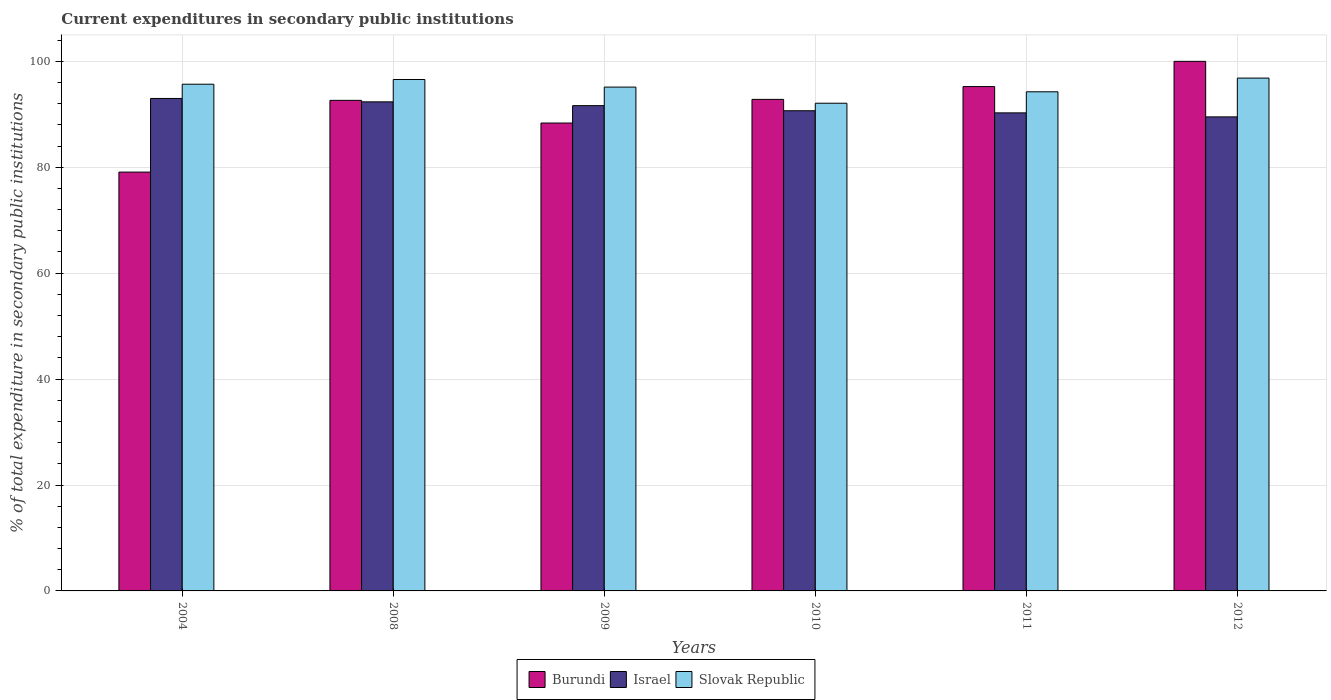How many different coloured bars are there?
Make the answer very short. 3. How many bars are there on the 1st tick from the right?
Offer a very short reply. 3. What is the current expenditures in secondary public institutions in Israel in 2012?
Your answer should be very brief. 89.51. Across all years, what is the maximum current expenditures in secondary public institutions in Slovak Republic?
Your response must be concise. 96.84. Across all years, what is the minimum current expenditures in secondary public institutions in Slovak Republic?
Keep it short and to the point. 92.09. In which year was the current expenditures in secondary public institutions in Slovak Republic maximum?
Ensure brevity in your answer.  2012. In which year was the current expenditures in secondary public institutions in Slovak Republic minimum?
Provide a short and direct response. 2010. What is the total current expenditures in secondary public institutions in Israel in the graph?
Keep it short and to the point. 547.41. What is the difference between the current expenditures in secondary public institutions in Israel in 2009 and that in 2012?
Offer a very short reply. 2.12. What is the difference between the current expenditures in secondary public institutions in Slovak Republic in 2008 and the current expenditures in secondary public institutions in Burundi in 2004?
Your response must be concise. 17.48. What is the average current expenditures in secondary public institutions in Israel per year?
Provide a succinct answer. 91.24. In the year 2008, what is the difference between the current expenditures in secondary public institutions in Slovak Republic and current expenditures in secondary public institutions in Israel?
Make the answer very short. 4.22. What is the ratio of the current expenditures in secondary public institutions in Burundi in 2009 to that in 2011?
Keep it short and to the point. 0.93. Is the difference between the current expenditures in secondary public institutions in Slovak Republic in 2008 and 2009 greater than the difference between the current expenditures in secondary public institutions in Israel in 2008 and 2009?
Keep it short and to the point. Yes. What is the difference between the highest and the second highest current expenditures in secondary public institutions in Israel?
Provide a succinct answer. 0.64. What is the difference between the highest and the lowest current expenditures in secondary public institutions in Israel?
Offer a terse response. 3.48. In how many years, is the current expenditures in secondary public institutions in Burundi greater than the average current expenditures in secondary public institutions in Burundi taken over all years?
Make the answer very short. 4. Is the sum of the current expenditures in secondary public institutions in Slovak Republic in 2011 and 2012 greater than the maximum current expenditures in secondary public institutions in Israel across all years?
Offer a terse response. Yes. What does the 2nd bar from the left in 2010 represents?
Make the answer very short. Israel. What does the 3rd bar from the right in 2009 represents?
Give a very brief answer. Burundi. Is it the case that in every year, the sum of the current expenditures in secondary public institutions in Burundi and current expenditures in secondary public institutions in Israel is greater than the current expenditures in secondary public institutions in Slovak Republic?
Your answer should be compact. Yes. Are all the bars in the graph horizontal?
Offer a terse response. No. How many years are there in the graph?
Your response must be concise. 6. What is the difference between two consecutive major ticks on the Y-axis?
Give a very brief answer. 20. Are the values on the major ticks of Y-axis written in scientific E-notation?
Make the answer very short. No. Where does the legend appear in the graph?
Provide a short and direct response. Bottom center. How are the legend labels stacked?
Your response must be concise. Horizontal. What is the title of the graph?
Your answer should be compact. Current expenditures in secondary public institutions. Does "Netherlands" appear as one of the legend labels in the graph?
Make the answer very short. No. What is the label or title of the Y-axis?
Your response must be concise. % of total expenditure in secondary public institutions. What is the % of total expenditure in secondary public institutions in Burundi in 2004?
Give a very brief answer. 79.09. What is the % of total expenditure in secondary public institutions in Israel in 2004?
Provide a succinct answer. 92.99. What is the % of total expenditure in secondary public institutions of Slovak Republic in 2004?
Your response must be concise. 95.68. What is the % of total expenditure in secondary public institutions in Burundi in 2008?
Ensure brevity in your answer.  92.63. What is the % of total expenditure in secondary public institutions in Israel in 2008?
Give a very brief answer. 92.35. What is the % of total expenditure in secondary public institutions of Slovak Republic in 2008?
Offer a very short reply. 96.57. What is the % of total expenditure in secondary public institutions of Burundi in 2009?
Provide a succinct answer. 88.35. What is the % of total expenditure in secondary public institutions in Israel in 2009?
Your answer should be compact. 91.63. What is the % of total expenditure in secondary public institutions in Slovak Republic in 2009?
Provide a short and direct response. 95.13. What is the % of total expenditure in secondary public institutions of Burundi in 2010?
Provide a succinct answer. 92.81. What is the % of total expenditure in secondary public institutions in Israel in 2010?
Make the answer very short. 90.67. What is the % of total expenditure in secondary public institutions of Slovak Republic in 2010?
Provide a short and direct response. 92.09. What is the % of total expenditure in secondary public institutions of Burundi in 2011?
Your answer should be compact. 95.23. What is the % of total expenditure in secondary public institutions of Israel in 2011?
Your answer should be compact. 90.27. What is the % of total expenditure in secondary public institutions of Slovak Republic in 2011?
Your answer should be compact. 94.25. What is the % of total expenditure in secondary public institutions in Burundi in 2012?
Ensure brevity in your answer.  100. What is the % of total expenditure in secondary public institutions in Israel in 2012?
Ensure brevity in your answer.  89.51. What is the % of total expenditure in secondary public institutions in Slovak Republic in 2012?
Offer a terse response. 96.84. Across all years, what is the maximum % of total expenditure in secondary public institutions in Burundi?
Provide a succinct answer. 100. Across all years, what is the maximum % of total expenditure in secondary public institutions in Israel?
Provide a succinct answer. 92.99. Across all years, what is the maximum % of total expenditure in secondary public institutions of Slovak Republic?
Provide a succinct answer. 96.84. Across all years, what is the minimum % of total expenditure in secondary public institutions of Burundi?
Keep it short and to the point. 79.09. Across all years, what is the minimum % of total expenditure in secondary public institutions of Israel?
Make the answer very short. 89.51. Across all years, what is the minimum % of total expenditure in secondary public institutions in Slovak Republic?
Provide a succinct answer. 92.09. What is the total % of total expenditure in secondary public institutions of Burundi in the graph?
Your answer should be compact. 548.11. What is the total % of total expenditure in secondary public institutions in Israel in the graph?
Keep it short and to the point. 547.41. What is the total % of total expenditure in secondary public institutions of Slovak Republic in the graph?
Offer a terse response. 570.56. What is the difference between the % of total expenditure in secondary public institutions of Burundi in 2004 and that in 2008?
Keep it short and to the point. -13.54. What is the difference between the % of total expenditure in secondary public institutions in Israel in 2004 and that in 2008?
Your answer should be very brief. 0.64. What is the difference between the % of total expenditure in secondary public institutions of Slovak Republic in 2004 and that in 2008?
Give a very brief answer. -0.89. What is the difference between the % of total expenditure in secondary public institutions of Burundi in 2004 and that in 2009?
Make the answer very short. -9.26. What is the difference between the % of total expenditure in secondary public institutions of Israel in 2004 and that in 2009?
Provide a succinct answer. 1.36. What is the difference between the % of total expenditure in secondary public institutions of Slovak Republic in 2004 and that in 2009?
Keep it short and to the point. 0.54. What is the difference between the % of total expenditure in secondary public institutions in Burundi in 2004 and that in 2010?
Your answer should be compact. -13.73. What is the difference between the % of total expenditure in secondary public institutions in Israel in 2004 and that in 2010?
Provide a succinct answer. 2.32. What is the difference between the % of total expenditure in secondary public institutions of Slovak Republic in 2004 and that in 2010?
Your response must be concise. 3.59. What is the difference between the % of total expenditure in secondary public institutions of Burundi in 2004 and that in 2011?
Offer a very short reply. -16.15. What is the difference between the % of total expenditure in secondary public institutions of Israel in 2004 and that in 2011?
Give a very brief answer. 2.72. What is the difference between the % of total expenditure in secondary public institutions of Slovak Republic in 2004 and that in 2011?
Keep it short and to the point. 1.43. What is the difference between the % of total expenditure in secondary public institutions of Burundi in 2004 and that in 2012?
Your answer should be compact. -20.91. What is the difference between the % of total expenditure in secondary public institutions in Israel in 2004 and that in 2012?
Keep it short and to the point. 3.48. What is the difference between the % of total expenditure in secondary public institutions of Slovak Republic in 2004 and that in 2012?
Your answer should be compact. -1.16. What is the difference between the % of total expenditure in secondary public institutions in Burundi in 2008 and that in 2009?
Offer a very short reply. 4.28. What is the difference between the % of total expenditure in secondary public institutions in Israel in 2008 and that in 2009?
Offer a terse response. 0.72. What is the difference between the % of total expenditure in secondary public institutions of Slovak Republic in 2008 and that in 2009?
Offer a very short reply. 1.43. What is the difference between the % of total expenditure in secondary public institutions in Burundi in 2008 and that in 2010?
Offer a very short reply. -0.18. What is the difference between the % of total expenditure in secondary public institutions in Israel in 2008 and that in 2010?
Your answer should be compact. 1.68. What is the difference between the % of total expenditure in secondary public institutions of Slovak Republic in 2008 and that in 2010?
Your response must be concise. 4.48. What is the difference between the % of total expenditure in secondary public institutions in Burundi in 2008 and that in 2011?
Your answer should be very brief. -2.6. What is the difference between the % of total expenditure in secondary public institutions of Israel in 2008 and that in 2011?
Offer a terse response. 2.08. What is the difference between the % of total expenditure in secondary public institutions in Slovak Republic in 2008 and that in 2011?
Your response must be concise. 2.32. What is the difference between the % of total expenditure in secondary public institutions in Burundi in 2008 and that in 2012?
Provide a short and direct response. -7.37. What is the difference between the % of total expenditure in secondary public institutions of Israel in 2008 and that in 2012?
Provide a succinct answer. 2.84. What is the difference between the % of total expenditure in secondary public institutions of Slovak Republic in 2008 and that in 2012?
Your answer should be very brief. -0.27. What is the difference between the % of total expenditure in secondary public institutions in Burundi in 2009 and that in 2010?
Give a very brief answer. -4.46. What is the difference between the % of total expenditure in secondary public institutions of Israel in 2009 and that in 2010?
Your answer should be compact. 0.96. What is the difference between the % of total expenditure in secondary public institutions in Slovak Republic in 2009 and that in 2010?
Provide a succinct answer. 3.05. What is the difference between the % of total expenditure in secondary public institutions of Burundi in 2009 and that in 2011?
Your response must be concise. -6.88. What is the difference between the % of total expenditure in secondary public institutions in Israel in 2009 and that in 2011?
Provide a short and direct response. 1.36. What is the difference between the % of total expenditure in secondary public institutions of Slovak Republic in 2009 and that in 2011?
Keep it short and to the point. 0.89. What is the difference between the % of total expenditure in secondary public institutions of Burundi in 2009 and that in 2012?
Provide a short and direct response. -11.64. What is the difference between the % of total expenditure in secondary public institutions of Israel in 2009 and that in 2012?
Make the answer very short. 2.12. What is the difference between the % of total expenditure in secondary public institutions in Slovak Republic in 2009 and that in 2012?
Offer a very short reply. -1.7. What is the difference between the % of total expenditure in secondary public institutions in Burundi in 2010 and that in 2011?
Make the answer very short. -2.42. What is the difference between the % of total expenditure in secondary public institutions in Israel in 2010 and that in 2011?
Make the answer very short. 0.4. What is the difference between the % of total expenditure in secondary public institutions in Slovak Republic in 2010 and that in 2011?
Give a very brief answer. -2.16. What is the difference between the % of total expenditure in secondary public institutions of Burundi in 2010 and that in 2012?
Give a very brief answer. -7.18. What is the difference between the % of total expenditure in secondary public institutions in Israel in 2010 and that in 2012?
Offer a terse response. 1.16. What is the difference between the % of total expenditure in secondary public institutions in Slovak Republic in 2010 and that in 2012?
Your answer should be very brief. -4.75. What is the difference between the % of total expenditure in secondary public institutions of Burundi in 2011 and that in 2012?
Your answer should be very brief. -4.76. What is the difference between the % of total expenditure in secondary public institutions in Israel in 2011 and that in 2012?
Your response must be concise. 0.76. What is the difference between the % of total expenditure in secondary public institutions in Slovak Republic in 2011 and that in 2012?
Your answer should be compact. -2.59. What is the difference between the % of total expenditure in secondary public institutions of Burundi in 2004 and the % of total expenditure in secondary public institutions of Israel in 2008?
Provide a succinct answer. -13.26. What is the difference between the % of total expenditure in secondary public institutions in Burundi in 2004 and the % of total expenditure in secondary public institutions in Slovak Republic in 2008?
Make the answer very short. -17.48. What is the difference between the % of total expenditure in secondary public institutions of Israel in 2004 and the % of total expenditure in secondary public institutions of Slovak Republic in 2008?
Make the answer very short. -3.58. What is the difference between the % of total expenditure in secondary public institutions of Burundi in 2004 and the % of total expenditure in secondary public institutions of Israel in 2009?
Give a very brief answer. -12.54. What is the difference between the % of total expenditure in secondary public institutions in Burundi in 2004 and the % of total expenditure in secondary public institutions in Slovak Republic in 2009?
Make the answer very short. -16.05. What is the difference between the % of total expenditure in secondary public institutions of Israel in 2004 and the % of total expenditure in secondary public institutions of Slovak Republic in 2009?
Ensure brevity in your answer.  -2.15. What is the difference between the % of total expenditure in secondary public institutions of Burundi in 2004 and the % of total expenditure in secondary public institutions of Israel in 2010?
Offer a terse response. -11.58. What is the difference between the % of total expenditure in secondary public institutions in Burundi in 2004 and the % of total expenditure in secondary public institutions in Slovak Republic in 2010?
Keep it short and to the point. -13. What is the difference between the % of total expenditure in secondary public institutions in Israel in 2004 and the % of total expenditure in secondary public institutions in Slovak Republic in 2010?
Ensure brevity in your answer.  0.9. What is the difference between the % of total expenditure in secondary public institutions in Burundi in 2004 and the % of total expenditure in secondary public institutions in Israel in 2011?
Your response must be concise. -11.18. What is the difference between the % of total expenditure in secondary public institutions of Burundi in 2004 and the % of total expenditure in secondary public institutions of Slovak Republic in 2011?
Make the answer very short. -15.16. What is the difference between the % of total expenditure in secondary public institutions in Israel in 2004 and the % of total expenditure in secondary public institutions in Slovak Republic in 2011?
Offer a terse response. -1.26. What is the difference between the % of total expenditure in secondary public institutions of Burundi in 2004 and the % of total expenditure in secondary public institutions of Israel in 2012?
Your answer should be very brief. -10.42. What is the difference between the % of total expenditure in secondary public institutions in Burundi in 2004 and the % of total expenditure in secondary public institutions in Slovak Republic in 2012?
Your answer should be very brief. -17.75. What is the difference between the % of total expenditure in secondary public institutions in Israel in 2004 and the % of total expenditure in secondary public institutions in Slovak Republic in 2012?
Give a very brief answer. -3.85. What is the difference between the % of total expenditure in secondary public institutions of Burundi in 2008 and the % of total expenditure in secondary public institutions of Israel in 2009?
Offer a very short reply. 1. What is the difference between the % of total expenditure in secondary public institutions in Burundi in 2008 and the % of total expenditure in secondary public institutions in Slovak Republic in 2009?
Offer a terse response. -2.5. What is the difference between the % of total expenditure in secondary public institutions in Israel in 2008 and the % of total expenditure in secondary public institutions in Slovak Republic in 2009?
Your answer should be compact. -2.79. What is the difference between the % of total expenditure in secondary public institutions of Burundi in 2008 and the % of total expenditure in secondary public institutions of Israel in 2010?
Provide a succinct answer. 1.96. What is the difference between the % of total expenditure in secondary public institutions of Burundi in 2008 and the % of total expenditure in secondary public institutions of Slovak Republic in 2010?
Keep it short and to the point. 0.54. What is the difference between the % of total expenditure in secondary public institutions in Israel in 2008 and the % of total expenditure in secondary public institutions in Slovak Republic in 2010?
Offer a very short reply. 0.26. What is the difference between the % of total expenditure in secondary public institutions of Burundi in 2008 and the % of total expenditure in secondary public institutions of Israel in 2011?
Provide a short and direct response. 2.36. What is the difference between the % of total expenditure in secondary public institutions in Burundi in 2008 and the % of total expenditure in secondary public institutions in Slovak Republic in 2011?
Your answer should be very brief. -1.62. What is the difference between the % of total expenditure in secondary public institutions of Israel in 2008 and the % of total expenditure in secondary public institutions of Slovak Republic in 2011?
Offer a terse response. -1.9. What is the difference between the % of total expenditure in secondary public institutions of Burundi in 2008 and the % of total expenditure in secondary public institutions of Israel in 2012?
Give a very brief answer. 3.12. What is the difference between the % of total expenditure in secondary public institutions of Burundi in 2008 and the % of total expenditure in secondary public institutions of Slovak Republic in 2012?
Make the answer very short. -4.21. What is the difference between the % of total expenditure in secondary public institutions in Israel in 2008 and the % of total expenditure in secondary public institutions in Slovak Republic in 2012?
Make the answer very short. -4.49. What is the difference between the % of total expenditure in secondary public institutions in Burundi in 2009 and the % of total expenditure in secondary public institutions in Israel in 2010?
Provide a succinct answer. -2.32. What is the difference between the % of total expenditure in secondary public institutions of Burundi in 2009 and the % of total expenditure in secondary public institutions of Slovak Republic in 2010?
Make the answer very short. -3.74. What is the difference between the % of total expenditure in secondary public institutions in Israel in 2009 and the % of total expenditure in secondary public institutions in Slovak Republic in 2010?
Your answer should be compact. -0.46. What is the difference between the % of total expenditure in secondary public institutions in Burundi in 2009 and the % of total expenditure in secondary public institutions in Israel in 2011?
Make the answer very short. -1.92. What is the difference between the % of total expenditure in secondary public institutions of Burundi in 2009 and the % of total expenditure in secondary public institutions of Slovak Republic in 2011?
Your answer should be compact. -5.9. What is the difference between the % of total expenditure in secondary public institutions in Israel in 2009 and the % of total expenditure in secondary public institutions in Slovak Republic in 2011?
Give a very brief answer. -2.62. What is the difference between the % of total expenditure in secondary public institutions in Burundi in 2009 and the % of total expenditure in secondary public institutions in Israel in 2012?
Ensure brevity in your answer.  -1.16. What is the difference between the % of total expenditure in secondary public institutions in Burundi in 2009 and the % of total expenditure in secondary public institutions in Slovak Republic in 2012?
Keep it short and to the point. -8.49. What is the difference between the % of total expenditure in secondary public institutions in Israel in 2009 and the % of total expenditure in secondary public institutions in Slovak Republic in 2012?
Offer a terse response. -5.21. What is the difference between the % of total expenditure in secondary public institutions in Burundi in 2010 and the % of total expenditure in secondary public institutions in Israel in 2011?
Your answer should be compact. 2.54. What is the difference between the % of total expenditure in secondary public institutions in Burundi in 2010 and the % of total expenditure in secondary public institutions in Slovak Republic in 2011?
Keep it short and to the point. -1.44. What is the difference between the % of total expenditure in secondary public institutions of Israel in 2010 and the % of total expenditure in secondary public institutions of Slovak Republic in 2011?
Your answer should be compact. -3.58. What is the difference between the % of total expenditure in secondary public institutions in Burundi in 2010 and the % of total expenditure in secondary public institutions in Israel in 2012?
Offer a terse response. 3.3. What is the difference between the % of total expenditure in secondary public institutions in Burundi in 2010 and the % of total expenditure in secondary public institutions in Slovak Republic in 2012?
Ensure brevity in your answer.  -4.02. What is the difference between the % of total expenditure in secondary public institutions in Israel in 2010 and the % of total expenditure in secondary public institutions in Slovak Republic in 2012?
Your answer should be compact. -6.17. What is the difference between the % of total expenditure in secondary public institutions in Burundi in 2011 and the % of total expenditure in secondary public institutions in Israel in 2012?
Provide a short and direct response. 5.73. What is the difference between the % of total expenditure in secondary public institutions in Burundi in 2011 and the % of total expenditure in secondary public institutions in Slovak Republic in 2012?
Provide a succinct answer. -1.6. What is the difference between the % of total expenditure in secondary public institutions of Israel in 2011 and the % of total expenditure in secondary public institutions of Slovak Republic in 2012?
Offer a very short reply. -6.57. What is the average % of total expenditure in secondary public institutions of Burundi per year?
Your answer should be compact. 91.35. What is the average % of total expenditure in secondary public institutions of Israel per year?
Keep it short and to the point. 91.24. What is the average % of total expenditure in secondary public institutions of Slovak Republic per year?
Your answer should be very brief. 95.09. In the year 2004, what is the difference between the % of total expenditure in secondary public institutions of Burundi and % of total expenditure in secondary public institutions of Israel?
Ensure brevity in your answer.  -13.9. In the year 2004, what is the difference between the % of total expenditure in secondary public institutions in Burundi and % of total expenditure in secondary public institutions in Slovak Republic?
Your response must be concise. -16.59. In the year 2004, what is the difference between the % of total expenditure in secondary public institutions in Israel and % of total expenditure in secondary public institutions in Slovak Republic?
Keep it short and to the point. -2.69. In the year 2008, what is the difference between the % of total expenditure in secondary public institutions of Burundi and % of total expenditure in secondary public institutions of Israel?
Your answer should be compact. 0.28. In the year 2008, what is the difference between the % of total expenditure in secondary public institutions in Burundi and % of total expenditure in secondary public institutions in Slovak Republic?
Provide a short and direct response. -3.94. In the year 2008, what is the difference between the % of total expenditure in secondary public institutions in Israel and % of total expenditure in secondary public institutions in Slovak Republic?
Offer a very short reply. -4.22. In the year 2009, what is the difference between the % of total expenditure in secondary public institutions in Burundi and % of total expenditure in secondary public institutions in Israel?
Your answer should be very brief. -3.28. In the year 2009, what is the difference between the % of total expenditure in secondary public institutions of Burundi and % of total expenditure in secondary public institutions of Slovak Republic?
Give a very brief answer. -6.78. In the year 2009, what is the difference between the % of total expenditure in secondary public institutions in Israel and % of total expenditure in secondary public institutions in Slovak Republic?
Ensure brevity in your answer.  -3.51. In the year 2010, what is the difference between the % of total expenditure in secondary public institutions of Burundi and % of total expenditure in secondary public institutions of Israel?
Provide a short and direct response. 2.14. In the year 2010, what is the difference between the % of total expenditure in secondary public institutions of Burundi and % of total expenditure in secondary public institutions of Slovak Republic?
Make the answer very short. 0.73. In the year 2010, what is the difference between the % of total expenditure in secondary public institutions of Israel and % of total expenditure in secondary public institutions of Slovak Republic?
Give a very brief answer. -1.42. In the year 2011, what is the difference between the % of total expenditure in secondary public institutions of Burundi and % of total expenditure in secondary public institutions of Israel?
Make the answer very short. 4.96. In the year 2011, what is the difference between the % of total expenditure in secondary public institutions in Burundi and % of total expenditure in secondary public institutions in Slovak Republic?
Provide a short and direct response. 0.99. In the year 2011, what is the difference between the % of total expenditure in secondary public institutions of Israel and % of total expenditure in secondary public institutions of Slovak Republic?
Give a very brief answer. -3.98. In the year 2012, what is the difference between the % of total expenditure in secondary public institutions in Burundi and % of total expenditure in secondary public institutions in Israel?
Provide a succinct answer. 10.49. In the year 2012, what is the difference between the % of total expenditure in secondary public institutions in Burundi and % of total expenditure in secondary public institutions in Slovak Republic?
Give a very brief answer. 3.16. In the year 2012, what is the difference between the % of total expenditure in secondary public institutions of Israel and % of total expenditure in secondary public institutions of Slovak Republic?
Keep it short and to the point. -7.33. What is the ratio of the % of total expenditure in secondary public institutions of Burundi in 2004 to that in 2008?
Your answer should be compact. 0.85. What is the ratio of the % of total expenditure in secondary public institutions of Israel in 2004 to that in 2008?
Your answer should be very brief. 1.01. What is the ratio of the % of total expenditure in secondary public institutions of Burundi in 2004 to that in 2009?
Your answer should be very brief. 0.9. What is the ratio of the % of total expenditure in secondary public institutions in Israel in 2004 to that in 2009?
Make the answer very short. 1.01. What is the ratio of the % of total expenditure in secondary public institutions in Slovak Republic in 2004 to that in 2009?
Make the answer very short. 1.01. What is the ratio of the % of total expenditure in secondary public institutions of Burundi in 2004 to that in 2010?
Your answer should be compact. 0.85. What is the ratio of the % of total expenditure in secondary public institutions in Israel in 2004 to that in 2010?
Your answer should be compact. 1.03. What is the ratio of the % of total expenditure in secondary public institutions of Slovak Republic in 2004 to that in 2010?
Make the answer very short. 1.04. What is the ratio of the % of total expenditure in secondary public institutions in Burundi in 2004 to that in 2011?
Your answer should be compact. 0.83. What is the ratio of the % of total expenditure in secondary public institutions of Israel in 2004 to that in 2011?
Give a very brief answer. 1.03. What is the ratio of the % of total expenditure in secondary public institutions of Slovak Republic in 2004 to that in 2011?
Ensure brevity in your answer.  1.02. What is the ratio of the % of total expenditure in secondary public institutions in Burundi in 2004 to that in 2012?
Give a very brief answer. 0.79. What is the ratio of the % of total expenditure in secondary public institutions in Israel in 2004 to that in 2012?
Your response must be concise. 1.04. What is the ratio of the % of total expenditure in secondary public institutions of Burundi in 2008 to that in 2009?
Keep it short and to the point. 1.05. What is the ratio of the % of total expenditure in secondary public institutions in Israel in 2008 to that in 2009?
Provide a short and direct response. 1.01. What is the ratio of the % of total expenditure in secondary public institutions in Slovak Republic in 2008 to that in 2009?
Make the answer very short. 1.02. What is the ratio of the % of total expenditure in secondary public institutions in Israel in 2008 to that in 2010?
Keep it short and to the point. 1.02. What is the ratio of the % of total expenditure in secondary public institutions in Slovak Republic in 2008 to that in 2010?
Provide a succinct answer. 1.05. What is the ratio of the % of total expenditure in secondary public institutions in Burundi in 2008 to that in 2011?
Give a very brief answer. 0.97. What is the ratio of the % of total expenditure in secondary public institutions in Israel in 2008 to that in 2011?
Your response must be concise. 1.02. What is the ratio of the % of total expenditure in secondary public institutions of Slovak Republic in 2008 to that in 2011?
Your answer should be compact. 1.02. What is the ratio of the % of total expenditure in secondary public institutions of Burundi in 2008 to that in 2012?
Provide a short and direct response. 0.93. What is the ratio of the % of total expenditure in secondary public institutions of Israel in 2008 to that in 2012?
Ensure brevity in your answer.  1.03. What is the ratio of the % of total expenditure in secondary public institutions of Slovak Republic in 2008 to that in 2012?
Your response must be concise. 1. What is the ratio of the % of total expenditure in secondary public institutions in Burundi in 2009 to that in 2010?
Your response must be concise. 0.95. What is the ratio of the % of total expenditure in secondary public institutions of Israel in 2009 to that in 2010?
Offer a very short reply. 1.01. What is the ratio of the % of total expenditure in secondary public institutions of Slovak Republic in 2009 to that in 2010?
Offer a terse response. 1.03. What is the ratio of the % of total expenditure in secondary public institutions of Burundi in 2009 to that in 2011?
Offer a very short reply. 0.93. What is the ratio of the % of total expenditure in secondary public institutions of Israel in 2009 to that in 2011?
Provide a short and direct response. 1.02. What is the ratio of the % of total expenditure in secondary public institutions in Slovak Republic in 2009 to that in 2011?
Offer a very short reply. 1.01. What is the ratio of the % of total expenditure in secondary public institutions in Burundi in 2009 to that in 2012?
Your answer should be very brief. 0.88. What is the ratio of the % of total expenditure in secondary public institutions of Israel in 2009 to that in 2012?
Make the answer very short. 1.02. What is the ratio of the % of total expenditure in secondary public institutions of Slovak Republic in 2009 to that in 2012?
Ensure brevity in your answer.  0.98. What is the ratio of the % of total expenditure in secondary public institutions in Burundi in 2010 to that in 2011?
Make the answer very short. 0.97. What is the ratio of the % of total expenditure in secondary public institutions in Israel in 2010 to that in 2011?
Your response must be concise. 1. What is the ratio of the % of total expenditure in secondary public institutions of Slovak Republic in 2010 to that in 2011?
Provide a succinct answer. 0.98. What is the ratio of the % of total expenditure in secondary public institutions in Burundi in 2010 to that in 2012?
Your response must be concise. 0.93. What is the ratio of the % of total expenditure in secondary public institutions in Slovak Republic in 2010 to that in 2012?
Ensure brevity in your answer.  0.95. What is the ratio of the % of total expenditure in secondary public institutions in Burundi in 2011 to that in 2012?
Your answer should be very brief. 0.95. What is the ratio of the % of total expenditure in secondary public institutions of Israel in 2011 to that in 2012?
Offer a very short reply. 1.01. What is the ratio of the % of total expenditure in secondary public institutions of Slovak Republic in 2011 to that in 2012?
Make the answer very short. 0.97. What is the difference between the highest and the second highest % of total expenditure in secondary public institutions in Burundi?
Offer a very short reply. 4.76. What is the difference between the highest and the second highest % of total expenditure in secondary public institutions of Israel?
Provide a succinct answer. 0.64. What is the difference between the highest and the second highest % of total expenditure in secondary public institutions of Slovak Republic?
Your answer should be compact. 0.27. What is the difference between the highest and the lowest % of total expenditure in secondary public institutions in Burundi?
Provide a short and direct response. 20.91. What is the difference between the highest and the lowest % of total expenditure in secondary public institutions of Israel?
Provide a succinct answer. 3.48. What is the difference between the highest and the lowest % of total expenditure in secondary public institutions of Slovak Republic?
Your answer should be very brief. 4.75. 